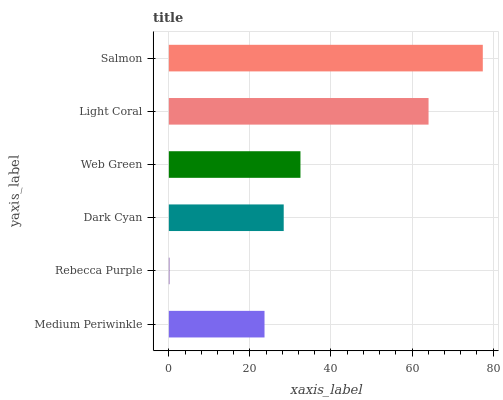Is Rebecca Purple the minimum?
Answer yes or no. Yes. Is Salmon the maximum?
Answer yes or no. Yes. Is Dark Cyan the minimum?
Answer yes or no. No. Is Dark Cyan the maximum?
Answer yes or no. No. Is Dark Cyan greater than Rebecca Purple?
Answer yes or no. Yes. Is Rebecca Purple less than Dark Cyan?
Answer yes or no. Yes. Is Rebecca Purple greater than Dark Cyan?
Answer yes or no. No. Is Dark Cyan less than Rebecca Purple?
Answer yes or no. No. Is Web Green the high median?
Answer yes or no. Yes. Is Dark Cyan the low median?
Answer yes or no. Yes. Is Salmon the high median?
Answer yes or no. No. Is Rebecca Purple the low median?
Answer yes or no. No. 